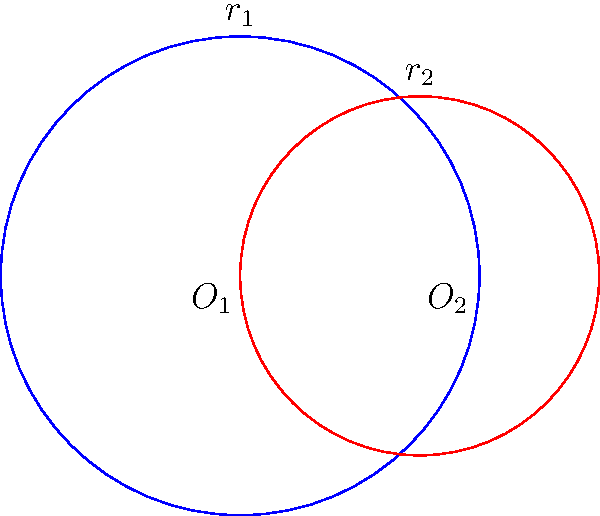In a traditional Native American story, the crescent moon shape is described as the intersection of two spirit circles. The larger circle, representing the Great Spirit, has a radius of 2 units, while the smaller circle, symbolizing the Earth Spirit, has a radius of 1.5 units. The centers of these circles are 1.5 units apart. Calculate the area of the crescent moon shape formed by these overlapping circles, rounding your answer to two decimal places. Let's approach this step-by-step, using the wisdom of geometry passed down through generations:

1) First, we need to find the area of intersection of the two circles. The formula for this is:

   $$A = r_1^2 \arccos(\frac{d^2 + r_1^2 - r_2^2}{2dr_1}) + r_2^2 \arccos(\frac{d^2 + r_2^2 - r_1^2}{2dr_2}) - \frac{1}{2}\sqrt{(-d+r_1+r_2)(d+r_1-r_2)(d-r_1+r_2)(d+r_1+r_2)}$$

   Where $r_1$ is the radius of the larger circle, $r_2$ is the radius of the smaller circle, and $d$ is the distance between their centers.

2) We know that $r_1 = 2$, $r_2 = 1.5$, and $d = 1.5$. Let's substitute these values:

   $$A = 2^2 \arccos(\frac{1.5^2 + 2^2 - 1.5^2}{2 * 1.5 * 2}) + 1.5^2 \arccos(\frac{1.5^2 + 1.5^2 - 2^2}{2 * 1.5 * 1.5}) - \frac{1}{2}\sqrt{(-1.5+2+1.5)(1.5+2-1.5)(1.5-2+1.5)(1.5+2+1.5)}$$

3) Simplify:
   
   $$A = 4 \arccos(0.75) + 2.25 \arccos(0.5) - \frac{1}{2}\sqrt{2 * 2 * 1 * 5}$$

4) Calculate:
   
   $$A \approx 4 * 0.7227 + 2.25 * 1.0472 - \frac{1}{2}\sqrt{20} \approx 2.8908 + 2.3562 - 2.2361 \approx 3.0109$$

5) The area of the crescent moon is the area of the larger circle minus the area of intersection:

   $$A_{crescent} = \pi r_1^2 - A$$
   $$A_{crescent} = \pi * 2^2 - 3.0109 \approx 12.5664 - 3.0109 \approx 9.5555$$

6) Rounding to two decimal places, we get 9.56 square units.
Answer: $9.56$ square units 